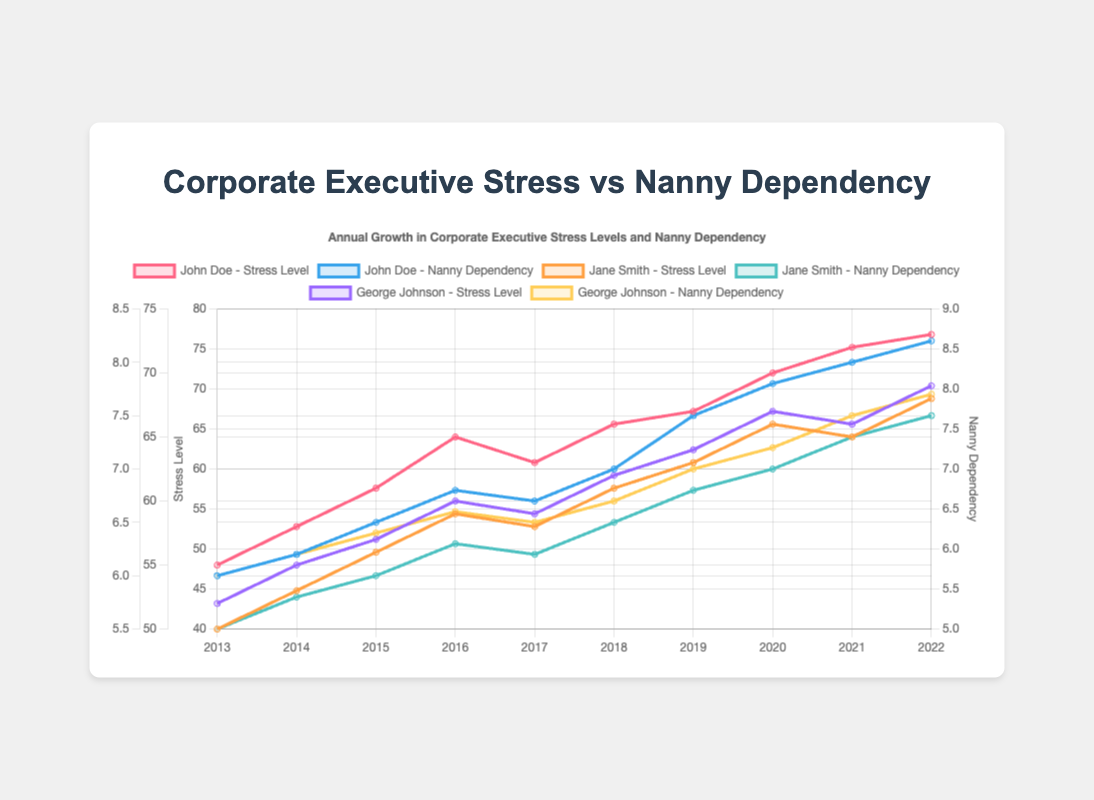What was the stress level of John Doe in 2018? The line labeled 'John Doe - Stress Level' shows John's stress level for each year. In 2018, the value directly on the line is 66.
Answer: 66 How much higher is George Johnson's stress level in 2022 compared to 2013? For 2022, George Johnson's stress level is 69. For 2013, it is 52. The difference is 69 - 52 = 17.
Answer: 17 Which executive had the highest nanny dependency in 2022? The line labeled 'Nanny Dependency' for each executive shows their dependency levels. In 2022, John Doe has the highest value of 8.2.
Answer: John Doe How does Jane Smith’s stress level in 2020 compare to her stress level in 2017? Jane's stress level in 2020 is 66, and in 2017 it is 58. Comparing the two, 66 is higher than 58.
Answer: Higher Calculate the average stress level of Jane Smith from 2016 to 2020. Jane’s stress levels from 2016 to 2020 are 59, 58, 61, 63, and 66. Sum those values: 59 + 58 + 61 + 63 + 66 = 307. Divide by the number of years, 307/5 = 61.4.
Answer: 61.4 Which year did John Doe experience the highest increase in stress level from the previous year? By calculating the year-on-year difference for John: 
2014-2013 = 58-55 = 3
2015-2014 = 61-58 = 3
2016-2015 = 65-61 = 4
2017-2016 = 63-65 = -2
2018-2017 = 66-63 = 3
2019-2018 = 67-66 = 1
2020-2019 = 70-67 = 3
2021-2020 = 72-70 = 2
2022-2021 = 73-72 = 1
The highest increase of 4 occurred between 2015 and 2016.
Answer: 2016 Compare George Johnson's nanny dependency in 2017 and 2021. Which year has a higher value? George Johnson's nanny dependency in 2017 is 6.5, and in 2021 it is 7.5. 2021 is higher.
Answer: 2021 By how much did Jane Smith's nanny dependency increase from 2013 to 2022? Jane Smith's nanny dependency in 2013 is 5.5 and in 2022 is 7.5. The increase is 7.5 - 5.5 = 2.
Answer: 2 